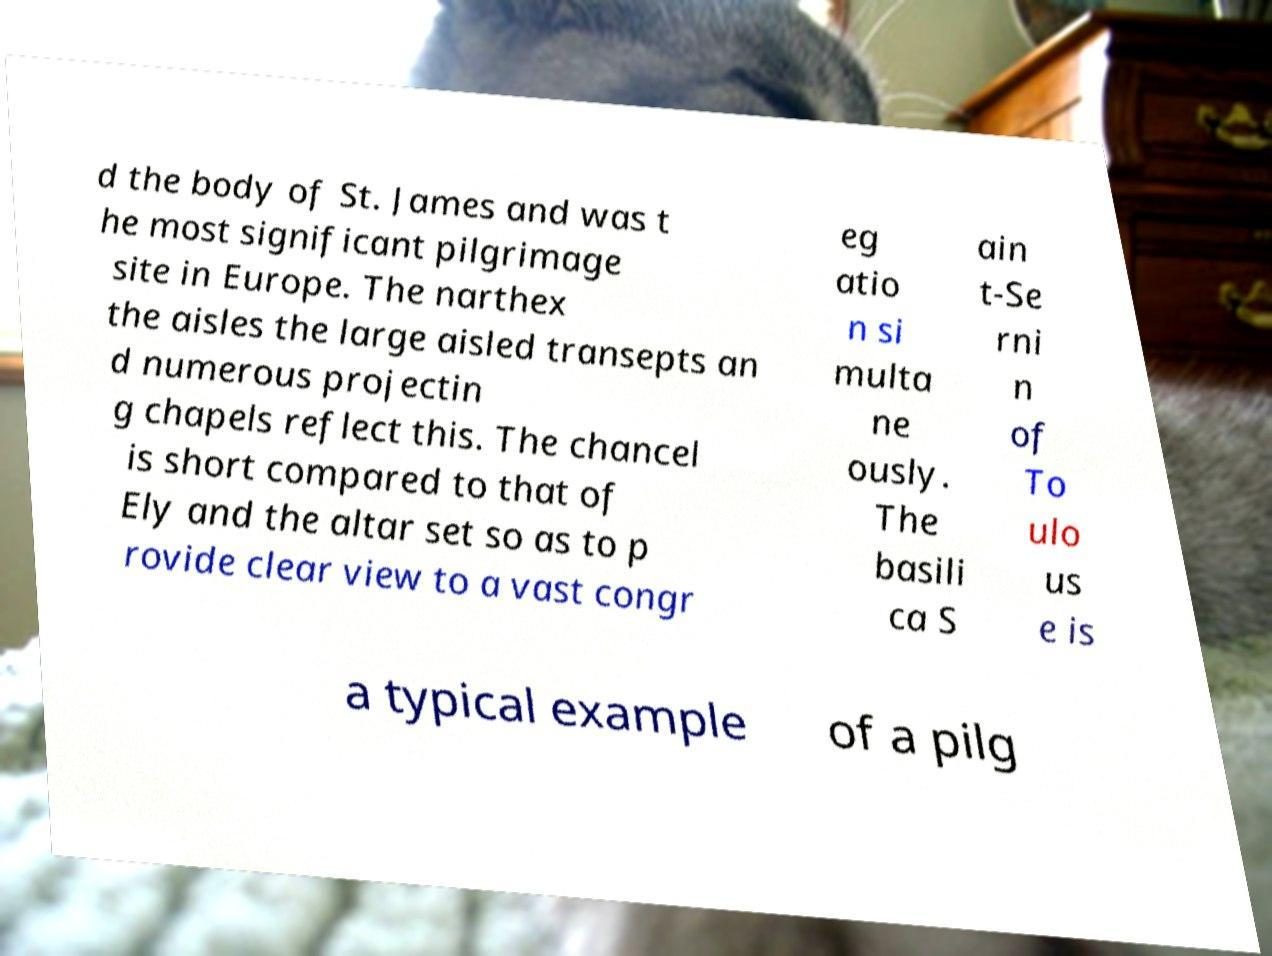What messages or text are displayed in this image? I need them in a readable, typed format. d the body of St. James and was t he most significant pilgrimage site in Europe. The narthex the aisles the large aisled transepts an d numerous projectin g chapels reflect this. The chancel is short compared to that of Ely and the altar set so as to p rovide clear view to a vast congr eg atio n si multa ne ously. The basili ca S ain t-Se rni n of To ulo us e is a typical example of a pilg 